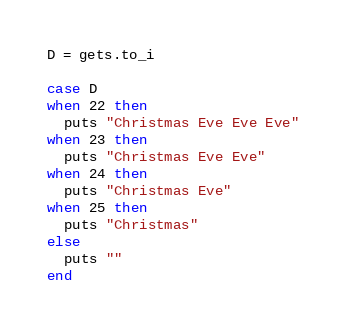Convert code to text. <code><loc_0><loc_0><loc_500><loc_500><_Ruby_>D = gets.to_i

case D
when 22 then
  puts "Christmas Eve Eve Eve"
when 23 then
  puts "Christmas Eve Eve"
when 24 then
  puts "Christmas Eve"
when 25 then
  puts "Christmas"
else
  puts ""
end</code> 